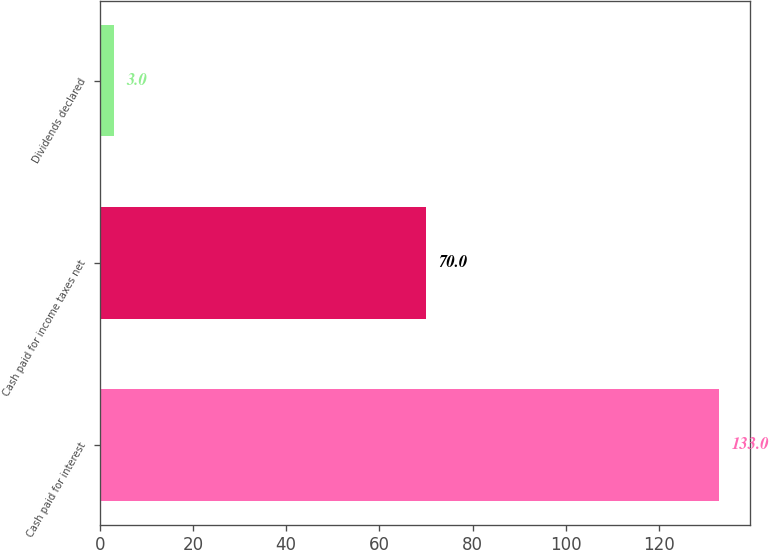<chart> <loc_0><loc_0><loc_500><loc_500><bar_chart><fcel>Cash paid for interest<fcel>Cash paid for income taxes net<fcel>Dividends declared<nl><fcel>133<fcel>70<fcel>3<nl></chart> 